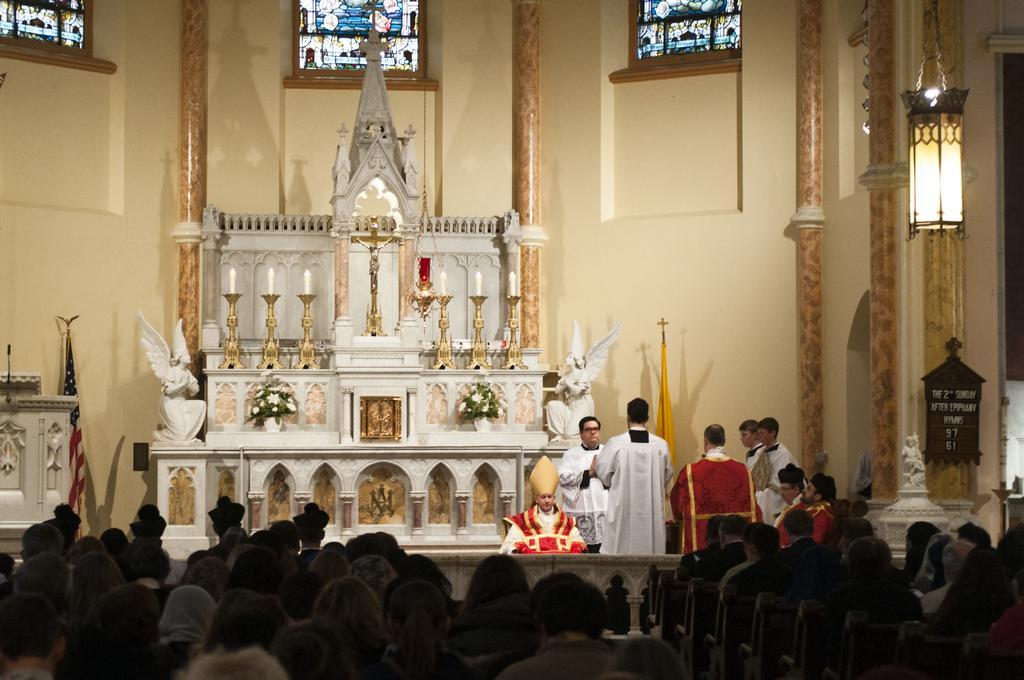Could you give a brief overview of what you see in this image? This image is taken from inside the church. In this image there are a few people sitting, in front of them there are a few people standing and one of them is sitting, there is a rocky structure on which there are two statues, flower pots, candles, cross, beside that there is a flag and in the background there is a wall and windows, on which there is painting. On the right side of the image there is a lamp hanging from the ceiling and there is a board with some text on it. 